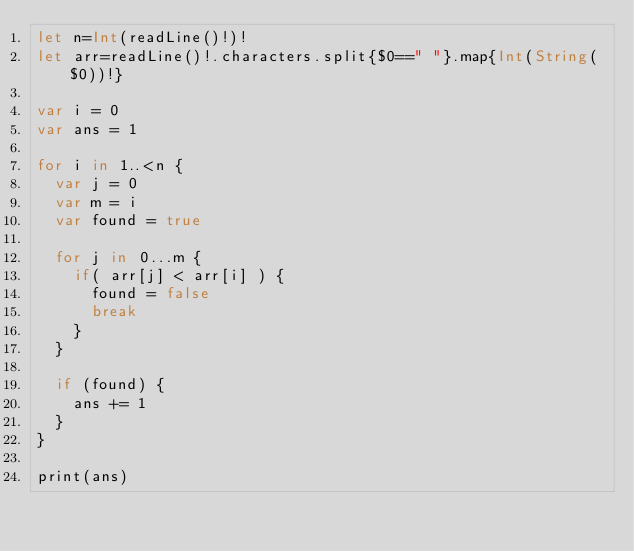Convert code to text. <code><loc_0><loc_0><loc_500><loc_500><_Swift_>let n=Int(readLine()!)!
let arr=readLine()!.characters.split{$0==" "}.map{Int(String($0))!}

var i = 0
var ans = 1

for i in 1..<n {
  var j = 0
  var m = i
  var found = true
  
  for j in 0...m {
    if( arr[j] < arr[i] ) {
      found = false
      break
    }
  }
  
  if (found) {
    ans += 1
  }
}

print(ans)</code> 